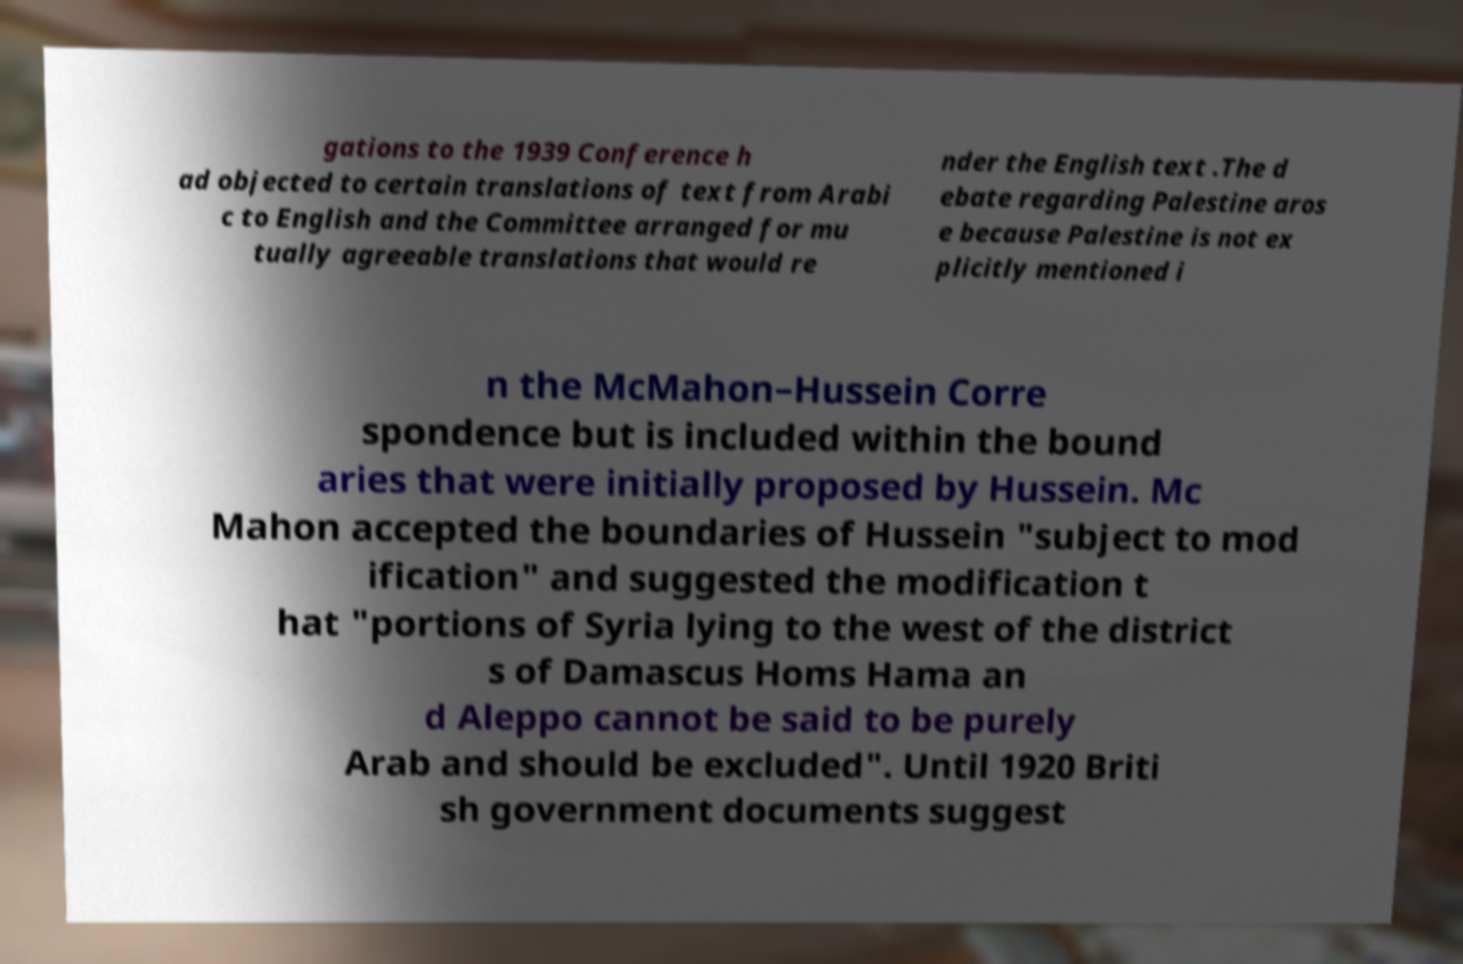Can you accurately transcribe the text from the provided image for me? gations to the 1939 Conference h ad objected to certain translations of text from Arabi c to English and the Committee arranged for mu tually agreeable translations that would re nder the English text .The d ebate regarding Palestine aros e because Palestine is not ex plicitly mentioned i n the McMahon–Hussein Corre spondence but is included within the bound aries that were initially proposed by Hussein. Mc Mahon accepted the boundaries of Hussein "subject to mod ification" and suggested the modification t hat "portions of Syria lying to the west of the district s of Damascus Homs Hama an d Aleppo cannot be said to be purely Arab and should be excluded". Until 1920 Briti sh government documents suggest 